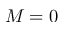<formula> <loc_0><loc_0><loc_500><loc_500>M = 0</formula> 